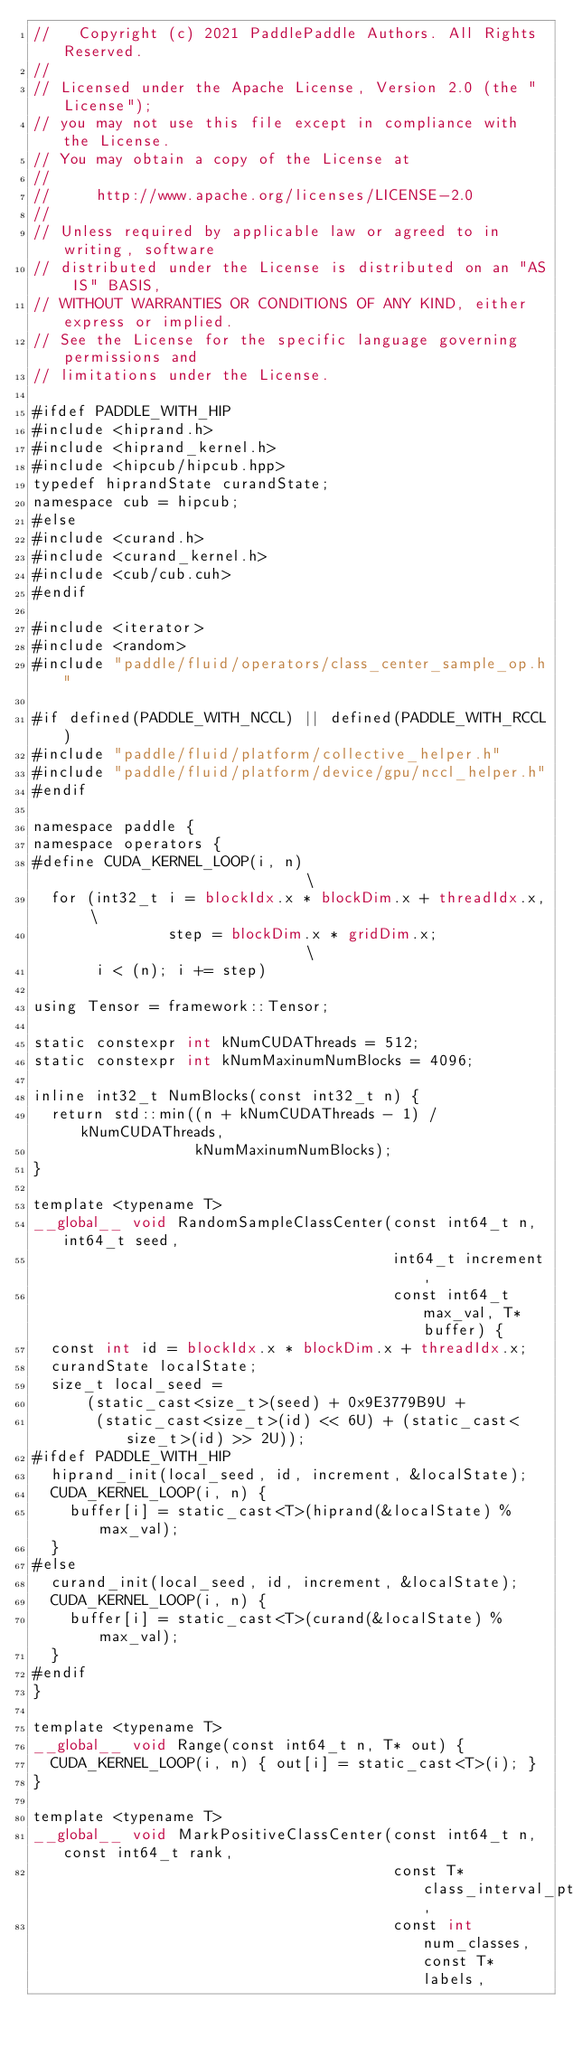Convert code to text. <code><loc_0><loc_0><loc_500><loc_500><_Cuda_>//   Copyright (c) 2021 PaddlePaddle Authors. All Rights Reserved.
//
// Licensed under the Apache License, Version 2.0 (the "License");
// you may not use this file except in compliance with the License.
// You may obtain a copy of the License at
//
//     http://www.apache.org/licenses/LICENSE-2.0
//
// Unless required by applicable law or agreed to in writing, software
// distributed under the License is distributed on an "AS IS" BASIS,
// WITHOUT WARRANTIES OR CONDITIONS OF ANY KIND, either express or implied.
// See the License for the specific language governing permissions and
// limitations under the License.

#ifdef PADDLE_WITH_HIP
#include <hiprand.h>
#include <hiprand_kernel.h>
#include <hipcub/hipcub.hpp>
typedef hiprandState curandState;
namespace cub = hipcub;
#else
#include <curand.h>
#include <curand_kernel.h>
#include <cub/cub.cuh>
#endif

#include <iterator>
#include <random>
#include "paddle/fluid/operators/class_center_sample_op.h"

#if defined(PADDLE_WITH_NCCL) || defined(PADDLE_WITH_RCCL)
#include "paddle/fluid/platform/collective_helper.h"
#include "paddle/fluid/platform/device/gpu/nccl_helper.h"
#endif

namespace paddle {
namespace operators {
#define CUDA_KERNEL_LOOP(i, n)                            \
  for (int32_t i = blockIdx.x * blockDim.x + threadIdx.x, \
               step = blockDim.x * gridDim.x;             \
       i < (n); i += step)

using Tensor = framework::Tensor;

static constexpr int kNumCUDAThreads = 512;
static constexpr int kNumMaxinumNumBlocks = 4096;

inline int32_t NumBlocks(const int32_t n) {
  return std::min((n + kNumCUDAThreads - 1) / kNumCUDAThreads,
                  kNumMaxinumNumBlocks);
}

template <typename T>
__global__ void RandomSampleClassCenter(const int64_t n, int64_t seed,
                                        int64_t increment,
                                        const int64_t max_val, T* buffer) {
  const int id = blockIdx.x * blockDim.x + threadIdx.x;
  curandState localState;
  size_t local_seed =
      (static_cast<size_t>(seed) + 0x9E3779B9U +
       (static_cast<size_t>(id) << 6U) + (static_cast<size_t>(id) >> 2U));
#ifdef PADDLE_WITH_HIP
  hiprand_init(local_seed, id, increment, &localState);
  CUDA_KERNEL_LOOP(i, n) {
    buffer[i] = static_cast<T>(hiprand(&localState) % max_val);
  }
#else
  curand_init(local_seed, id, increment, &localState);
  CUDA_KERNEL_LOOP(i, n) {
    buffer[i] = static_cast<T>(curand(&localState) % max_val);
  }
#endif
}

template <typename T>
__global__ void Range(const int64_t n, T* out) {
  CUDA_KERNEL_LOOP(i, n) { out[i] = static_cast<T>(i); }
}

template <typename T>
__global__ void MarkPositiveClassCenter(const int64_t n, const int64_t rank,
                                        const T* class_interval_ptr,
                                        const int num_classes, const T* labels,</code> 